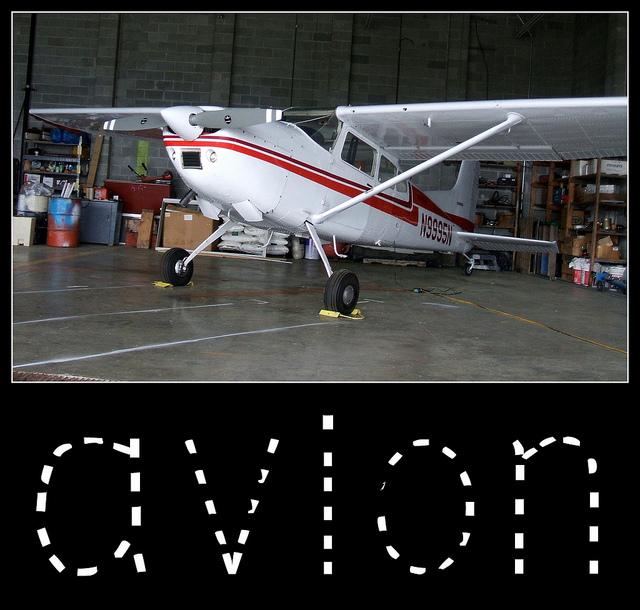What are the letters that spell avion made of?
Give a very brief answer. Dashes. What type of plane is this?
Concise answer only. Avion. Is there a star on the plane?
Concise answer only. No. How many wheels are there?
Short answer required. 3. 